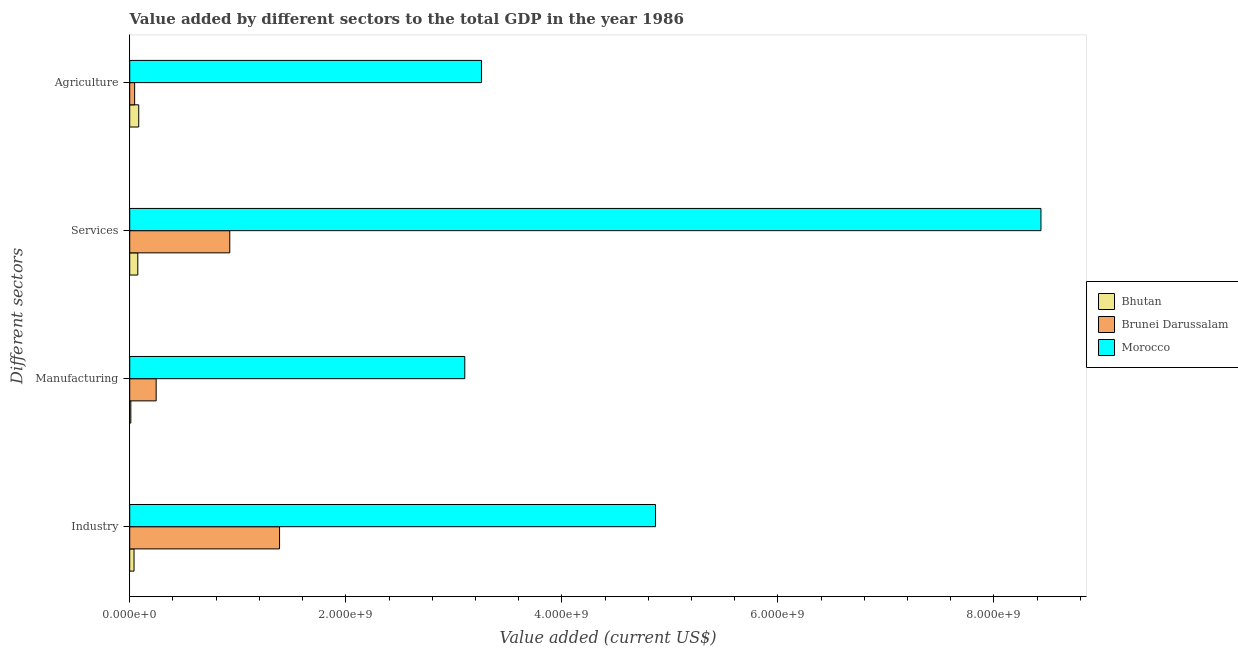How many different coloured bars are there?
Offer a very short reply. 3. Are the number of bars per tick equal to the number of legend labels?
Your answer should be compact. Yes. How many bars are there on the 3rd tick from the top?
Give a very brief answer. 3. How many bars are there on the 1st tick from the bottom?
Your response must be concise. 3. What is the label of the 2nd group of bars from the top?
Ensure brevity in your answer.  Services. What is the value added by manufacturing sector in Brunei Darussalam?
Make the answer very short. 2.45e+08. Across all countries, what is the maximum value added by industrial sector?
Your answer should be compact. 4.87e+09. Across all countries, what is the minimum value added by agricultural sector?
Ensure brevity in your answer.  4.55e+07. In which country was the value added by services sector maximum?
Your answer should be very brief. Morocco. In which country was the value added by manufacturing sector minimum?
Ensure brevity in your answer.  Bhutan. What is the total value added by industrial sector in the graph?
Your answer should be very brief. 6.29e+09. What is the difference between the value added by services sector in Brunei Darussalam and that in Morocco?
Your response must be concise. -7.51e+09. What is the difference between the value added by manufacturing sector in Bhutan and the value added by services sector in Brunei Darussalam?
Keep it short and to the point. -9.16e+08. What is the average value added by agricultural sector per country?
Keep it short and to the point. 1.13e+09. What is the difference between the value added by industrial sector and value added by agricultural sector in Bhutan?
Your response must be concise. -4.35e+07. What is the ratio of the value added by agricultural sector in Bhutan to that in Morocco?
Provide a succinct answer. 0.03. Is the difference between the value added by services sector in Morocco and Brunei Darussalam greater than the difference between the value added by industrial sector in Morocco and Brunei Darussalam?
Provide a short and direct response. Yes. What is the difference between the highest and the second highest value added by services sector?
Ensure brevity in your answer.  7.51e+09. What is the difference between the highest and the lowest value added by manufacturing sector?
Offer a very short reply. 3.09e+09. In how many countries, is the value added by services sector greater than the average value added by services sector taken over all countries?
Your answer should be compact. 1. Is the sum of the value added by industrial sector in Brunei Darussalam and Morocco greater than the maximum value added by manufacturing sector across all countries?
Your response must be concise. Yes. What does the 2nd bar from the top in Manufacturing represents?
Offer a terse response. Brunei Darussalam. What does the 2nd bar from the bottom in Services represents?
Provide a short and direct response. Brunei Darussalam. How many bars are there?
Give a very brief answer. 12. How many countries are there in the graph?
Your answer should be compact. 3. What is the difference between two consecutive major ticks on the X-axis?
Give a very brief answer. 2.00e+09. Does the graph contain any zero values?
Ensure brevity in your answer.  No. Does the graph contain grids?
Keep it short and to the point. No. How are the legend labels stacked?
Make the answer very short. Vertical. What is the title of the graph?
Provide a succinct answer. Value added by different sectors to the total GDP in the year 1986. Does "South Africa" appear as one of the legend labels in the graph?
Provide a short and direct response. No. What is the label or title of the X-axis?
Keep it short and to the point. Value added (current US$). What is the label or title of the Y-axis?
Your answer should be compact. Different sectors. What is the Value added (current US$) of Bhutan in Industry?
Your answer should be compact. 3.98e+07. What is the Value added (current US$) of Brunei Darussalam in Industry?
Provide a succinct answer. 1.39e+09. What is the Value added (current US$) in Morocco in Industry?
Your answer should be very brief. 4.87e+09. What is the Value added (current US$) in Bhutan in Manufacturing?
Make the answer very short. 1.02e+07. What is the Value added (current US$) in Brunei Darussalam in Manufacturing?
Make the answer very short. 2.45e+08. What is the Value added (current US$) in Morocco in Manufacturing?
Provide a succinct answer. 3.10e+09. What is the Value added (current US$) of Bhutan in Services?
Provide a succinct answer. 7.48e+07. What is the Value added (current US$) in Brunei Darussalam in Services?
Provide a succinct answer. 9.26e+08. What is the Value added (current US$) of Morocco in Services?
Make the answer very short. 8.44e+09. What is the Value added (current US$) in Bhutan in Agriculture?
Your response must be concise. 8.34e+07. What is the Value added (current US$) of Brunei Darussalam in Agriculture?
Keep it short and to the point. 4.55e+07. What is the Value added (current US$) of Morocco in Agriculture?
Give a very brief answer. 3.26e+09. Across all Different sectors, what is the maximum Value added (current US$) in Bhutan?
Your answer should be very brief. 8.34e+07. Across all Different sectors, what is the maximum Value added (current US$) of Brunei Darussalam?
Make the answer very short. 1.39e+09. Across all Different sectors, what is the maximum Value added (current US$) in Morocco?
Provide a succinct answer. 8.44e+09. Across all Different sectors, what is the minimum Value added (current US$) of Bhutan?
Provide a succinct answer. 1.02e+07. Across all Different sectors, what is the minimum Value added (current US$) of Brunei Darussalam?
Keep it short and to the point. 4.55e+07. Across all Different sectors, what is the minimum Value added (current US$) in Morocco?
Give a very brief answer. 3.10e+09. What is the total Value added (current US$) in Bhutan in the graph?
Offer a very short reply. 2.08e+08. What is the total Value added (current US$) in Brunei Darussalam in the graph?
Give a very brief answer. 2.60e+09. What is the total Value added (current US$) in Morocco in the graph?
Ensure brevity in your answer.  1.97e+1. What is the difference between the Value added (current US$) in Bhutan in Industry and that in Manufacturing?
Make the answer very short. 2.96e+07. What is the difference between the Value added (current US$) of Brunei Darussalam in Industry and that in Manufacturing?
Keep it short and to the point. 1.14e+09. What is the difference between the Value added (current US$) of Morocco in Industry and that in Manufacturing?
Your response must be concise. 1.77e+09. What is the difference between the Value added (current US$) of Bhutan in Industry and that in Services?
Provide a short and direct response. -3.50e+07. What is the difference between the Value added (current US$) of Brunei Darussalam in Industry and that in Services?
Your response must be concise. 4.61e+08. What is the difference between the Value added (current US$) in Morocco in Industry and that in Services?
Offer a terse response. -3.57e+09. What is the difference between the Value added (current US$) of Bhutan in Industry and that in Agriculture?
Your answer should be compact. -4.35e+07. What is the difference between the Value added (current US$) of Brunei Darussalam in Industry and that in Agriculture?
Your answer should be compact. 1.34e+09. What is the difference between the Value added (current US$) of Morocco in Industry and that in Agriculture?
Make the answer very short. 1.61e+09. What is the difference between the Value added (current US$) in Bhutan in Manufacturing and that in Services?
Provide a succinct answer. -6.46e+07. What is the difference between the Value added (current US$) of Brunei Darussalam in Manufacturing and that in Services?
Your answer should be very brief. -6.81e+08. What is the difference between the Value added (current US$) in Morocco in Manufacturing and that in Services?
Provide a succinct answer. -5.33e+09. What is the difference between the Value added (current US$) of Bhutan in Manufacturing and that in Agriculture?
Your answer should be very brief. -7.31e+07. What is the difference between the Value added (current US$) in Brunei Darussalam in Manufacturing and that in Agriculture?
Offer a very short reply. 1.99e+08. What is the difference between the Value added (current US$) in Morocco in Manufacturing and that in Agriculture?
Provide a succinct answer. -1.54e+08. What is the difference between the Value added (current US$) of Bhutan in Services and that in Agriculture?
Your response must be concise. -8.57e+06. What is the difference between the Value added (current US$) of Brunei Darussalam in Services and that in Agriculture?
Ensure brevity in your answer.  8.81e+08. What is the difference between the Value added (current US$) in Morocco in Services and that in Agriculture?
Offer a very short reply. 5.18e+09. What is the difference between the Value added (current US$) of Bhutan in Industry and the Value added (current US$) of Brunei Darussalam in Manufacturing?
Offer a very short reply. -2.05e+08. What is the difference between the Value added (current US$) of Bhutan in Industry and the Value added (current US$) of Morocco in Manufacturing?
Provide a short and direct response. -3.06e+09. What is the difference between the Value added (current US$) in Brunei Darussalam in Industry and the Value added (current US$) in Morocco in Manufacturing?
Your response must be concise. -1.71e+09. What is the difference between the Value added (current US$) in Bhutan in Industry and the Value added (current US$) in Brunei Darussalam in Services?
Your response must be concise. -8.86e+08. What is the difference between the Value added (current US$) in Bhutan in Industry and the Value added (current US$) in Morocco in Services?
Your answer should be very brief. -8.40e+09. What is the difference between the Value added (current US$) of Brunei Darussalam in Industry and the Value added (current US$) of Morocco in Services?
Keep it short and to the point. -7.05e+09. What is the difference between the Value added (current US$) of Bhutan in Industry and the Value added (current US$) of Brunei Darussalam in Agriculture?
Provide a succinct answer. -5.65e+06. What is the difference between the Value added (current US$) in Bhutan in Industry and the Value added (current US$) in Morocco in Agriculture?
Provide a succinct answer. -3.22e+09. What is the difference between the Value added (current US$) in Brunei Darussalam in Industry and the Value added (current US$) in Morocco in Agriculture?
Provide a succinct answer. -1.87e+09. What is the difference between the Value added (current US$) of Bhutan in Manufacturing and the Value added (current US$) of Brunei Darussalam in Services?
Your answer should be compact. -9.16e+08. What is the difference between the Value added (current US$) in Bhutan in Manufacturing and the Value added (current US$) in Morocco in Services?
Provide a short and direct response. -8.42e+09. What is the difference between the Value added (current US$) of Brunei Darussalam in Manufacturing and the Value added (current US$) of Morocco in Services?
Provide a succinct answer. -8.19e+09. What is the difference between the Value added (current US$) in Bhutan in Manufacturing and the Value added (current US$) in Brunei Darussalam in Agriculture?
Provide a succinct answer. -3.53e+07. What is the difference between the Value added (current US$) of Bhutan in Manufacturing and the Value added (current US$) of Morocco in Agriculture?
Give a very brief answer. -3.25e+09. What is the difference between the Value added (current US$) of Brunei Darussalam in Manufacturing and the Value added (current US$) of Morocco in Agriculture?
Provide a short and direct response. -3.01e+09. What is the difference between the Value added (current US$) in Bhutan in Services and the Value added (current US$) in Brunei Darussalam in Agriculture?
Give a very brief answer. 2.93e+07. What is the difference between the Value added (current US$) of Bhutan in Services and the Value added (current US$) of Morocco in Agriculture?
Keep it short and to the point. -3.18e+09. What is the difference between the Value added (current US$) in Brunei Darussalam in Services and the Value added (current US$) in Morocco in Agriculture?
Your response must be concise. -2.33e+09. What is the average Value added (current US$) in Bhutan per Different sectors?
Your answer should be very brief. 5.20e+07. What is the average Value added (current US$) in Brunei Darussalam per Different sectors?
Provide a short and direct response. 6.51e+08. What is the average Value added (current US$) in Morocco per Different sectors?
Offer a terse response. 4.91e+09. What is the difference between the Value added (current US$) in Bhutan and Value added (current US$) in Brunei Darussalam in Industry?
Make the answer very short. -1.35e+09. What is the difference between the Value added (current US$) in Bhutan and Value added (current US$) in Morocco in Industry?
Provide a short and direct response. -4.83e+09. What is the difference between the Value added (current US$) of Brunei Darussalam and Value added (current US$) of Morocco in Industry?
Your response must be concise. -3.48e+09. What is the difference between the Value added (current US$) in Bhutan and Value added (current US$) in Brunei Darussalam in Manufacturing?
Provide a succinct answer. -2.35e+08. What is the difference between the Value added (current US$) of Bhutan and Value added (current US$) of Morocco in Manufacturing?
Make the answer very short. -3.09e+09. What is the difference between the Value added (current US$) of Brunei Darussalam and Value added (current US$) of Morocco in Manufacturing?
Ensure brevity in your answer.  -2.86e+09. What is the difference between the Value added (current US$) in Bhutan and Value added (current US$) in Brunei Darussalam in Services?
Your answer should be very brief. -8.51e+08. What is the difference between the Value added (current US$) of Bhutan and Value added (current US$) of Morocco in Services?
Your answer should be very brief. -8.36e+09. What is the difference between the Value added (current US$) in Brunei Darussalam and Value added (current US$) in Morocco in Services?
Make the answer very short. -7.51e+09. What is the difference between the Value added (current US$) in Bhutan and Value added (current US$) in Brunei Darussalam in Agriculture?
Offer a very short reply. 3.79e+07. What is the difference between the Value added (current US$) of Bhutan and Value added (current US$) of Morocco in Agriculture?
Your response must be concise. -3.17e+09. What is the difference between the Value added (current US$) in Brunei Darussalam and Value added (current US$) in Morocco in Agriculture?
Your answer should be compact. -3.21e+09. What is the ratio of the Value added (current US$) of Bhutan in Industry to that in Manufacturing?
Your response must be concise. 3.9. What is the ratio of the Value added (current US$) of Brunei Darussalam in Industry to that in Manufacturing?
Your answer should be compact. 5.67. What is the ratio of the Value added (current US$) in Morocco in Industry to that in Manufacturing?
Keep it short and to the point. 1.57. What is the ratio of the Value added (current US$) of Bhutan in Industry to that in Services?
Ensure brevity in your answer.  0.53. What is the ratio of the Value added (current US$) in Brunei Darussalam in Industry to that in Services?
Keep it short and to the point. 1.5. What is the ratio of the Value added (current US$) of Morocco in Industry to that in Services?
Make the answer very short. 0.58. What is the ratio of the Value added (current US$) in Bhutan in Industry to that in Agriculture?
Your answer should be compact. 0.48. What is the ratio of the Value added (current US$) of Brunei Darussalam in Industry to that in Agriculture?
Offer a very short reply. 30.51. What is the ratio of the Value added (current US$) in Morocco in Industry to that in Agriculture?
Provide a short and direct response. 1.49. What is the ratio of the Value added (current US$) of Bhutan in Manufacturing to that in Services?
Your response must be concise. 0.14. What is the ratio of the Value added (current US$) in Brunei Darussalam in Manufacturing to that in Services?
Ensure brevity in your answer.  0.26. What is the ratio of the Value added (current US$) of Morocco in Manufacturing to that in Services?
Keep it short and to the point. 0.37. What is the ratio of the Value added (current US$) of Bhutan in Manufacturing to that in Agriculture?
Give a very brief answer. 0.12. What is the ratio of the Value added (current US$) of Brunei Darussalam in Manufacturing to that in Agriculture?
Keep it short and to the point. 5.38. What is the ratio of the Value added (current US$) in Morocco in Manufacturing to that in Agriculture?
Keep it short and to the point. 0.95. What is the ratio of the Value added (current US$) in Bhutan in Services to that in Agriculture?
Keep it short and to the point. 0.9. What is the ratio of the Value added (current US$) in Brunei Darussalam in Services to that in Agriculture?
Make the answer very short. 20.37. What is the ratio of the Value added (current US$) in Morocco in Services to that in Agriculture?
Give a very brief answer. 2.59. What is the difference between the highest and the second highest Value added (current US$) of Bhutan?
Give a very brief answer. 8.57e+06. What is the difference between the highest and the second highest Value added (current US$) of Brunei Darussalam?
Offer a very short reply. 4.61e+08. What is the difference between the highest and the second highest Value added (current US$) of Morocco?
Your response must be concise. 3.57e+09. What is the difference between the highest and the lowest Value added (current US$) in Bhutan?
Give a very brief answer. 7.31e+07. What is the difference between the highest and the lowest Value added (current US$) in Brunei Darussalam?
Give a very brief answer. 1.34e+09. What is the difference between the highest and the lowest Value added (current US$) of Morocco?
Ensure brevity in your answer.  5.33e+09. 